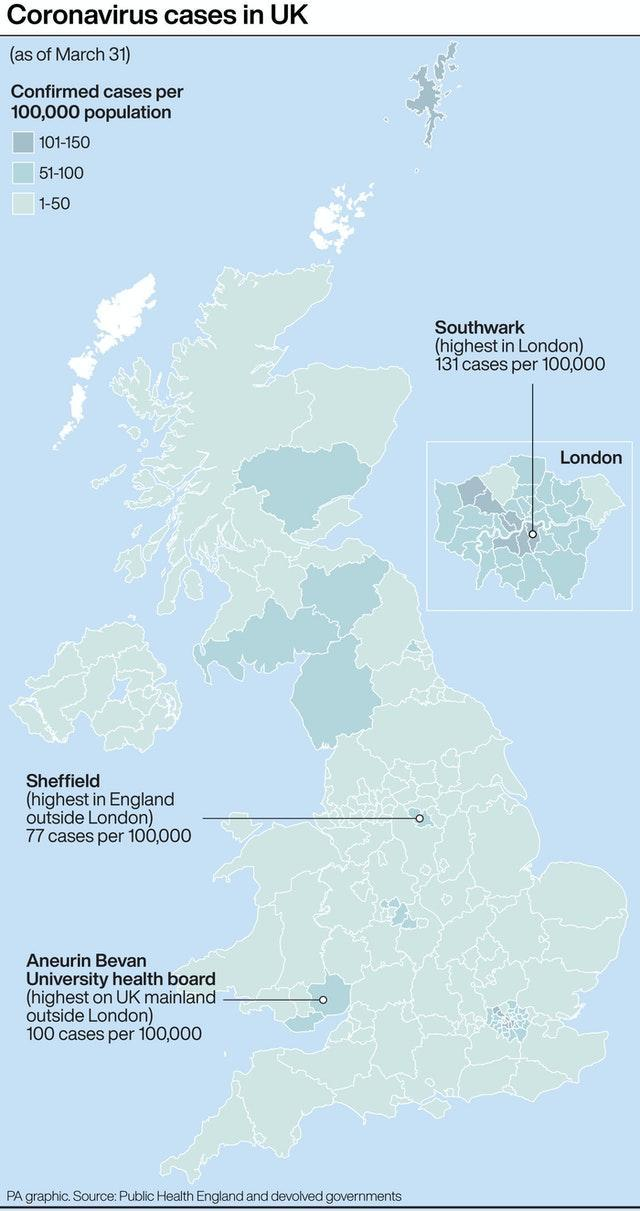Which place has the highest no of corona cases outside London?
Answer the question with a short phrase. 100 cases Majority of the corona cases in UK falls in which range? 1-50 Cases in "Southwark" falls is in which range? 101-150 